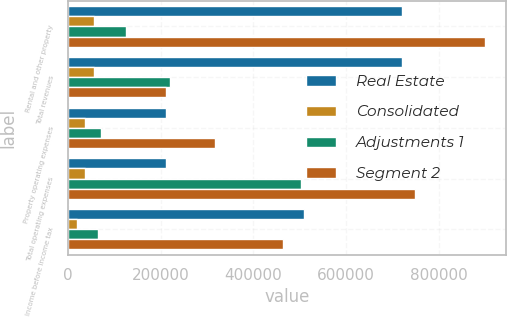Convert chart to OTSL. <chart><loc_0><loc_0><loc_500><loc_500><stacked_bar_chart><ecel><fcel>Rental and other property<fcel>Total revenues<fcel>Property operating expenses<fcel>Total operating expenses<fcel>Income before income tax<nl><fcel>Real Estate<fcel>720302<fcel>720302<fcel>210426<fcel>210426<fcel>509876<nl><fcel>Consolidated<fcel>55257<fcel>55257<fcel>35468<fcel>35468<fcel>19789<nl><fcel>Adjustments 1<fcel>124332<fcel>220295<fcel>72063<fcel>503164<fcel>65234<nl><fcel>Segment 2<fcel>899891<fcel>210426<fcel>317957<fcel>749058<fcel>464431<nl></chart> 